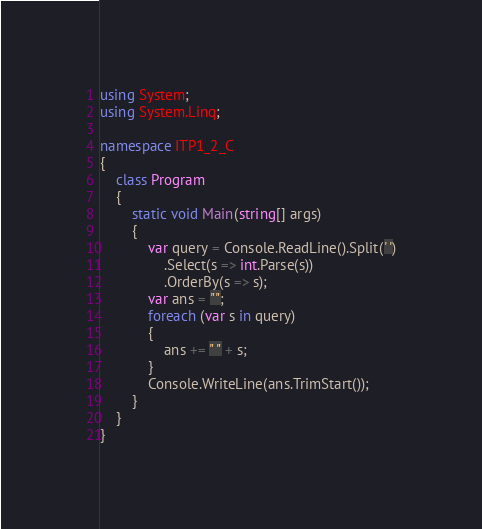<code> <loc_0><loc_0><loc_500><loc_500><_C#_>using System;
using System.Linq;

namespace ITP1_2_C
{
    class Program
    {
        static void Main(string[] args)
        {
            var query = Console.ReadLine().Split(' ')
                .Select(s => int.Parse(s))
                .OrderBy(s => s);
            var ans = "";
            foreach (var s in query)
            {
                ans += " " + s;
            }
            Console.WriteLine(ans.TrimStart());
        }
    }
}</code> 